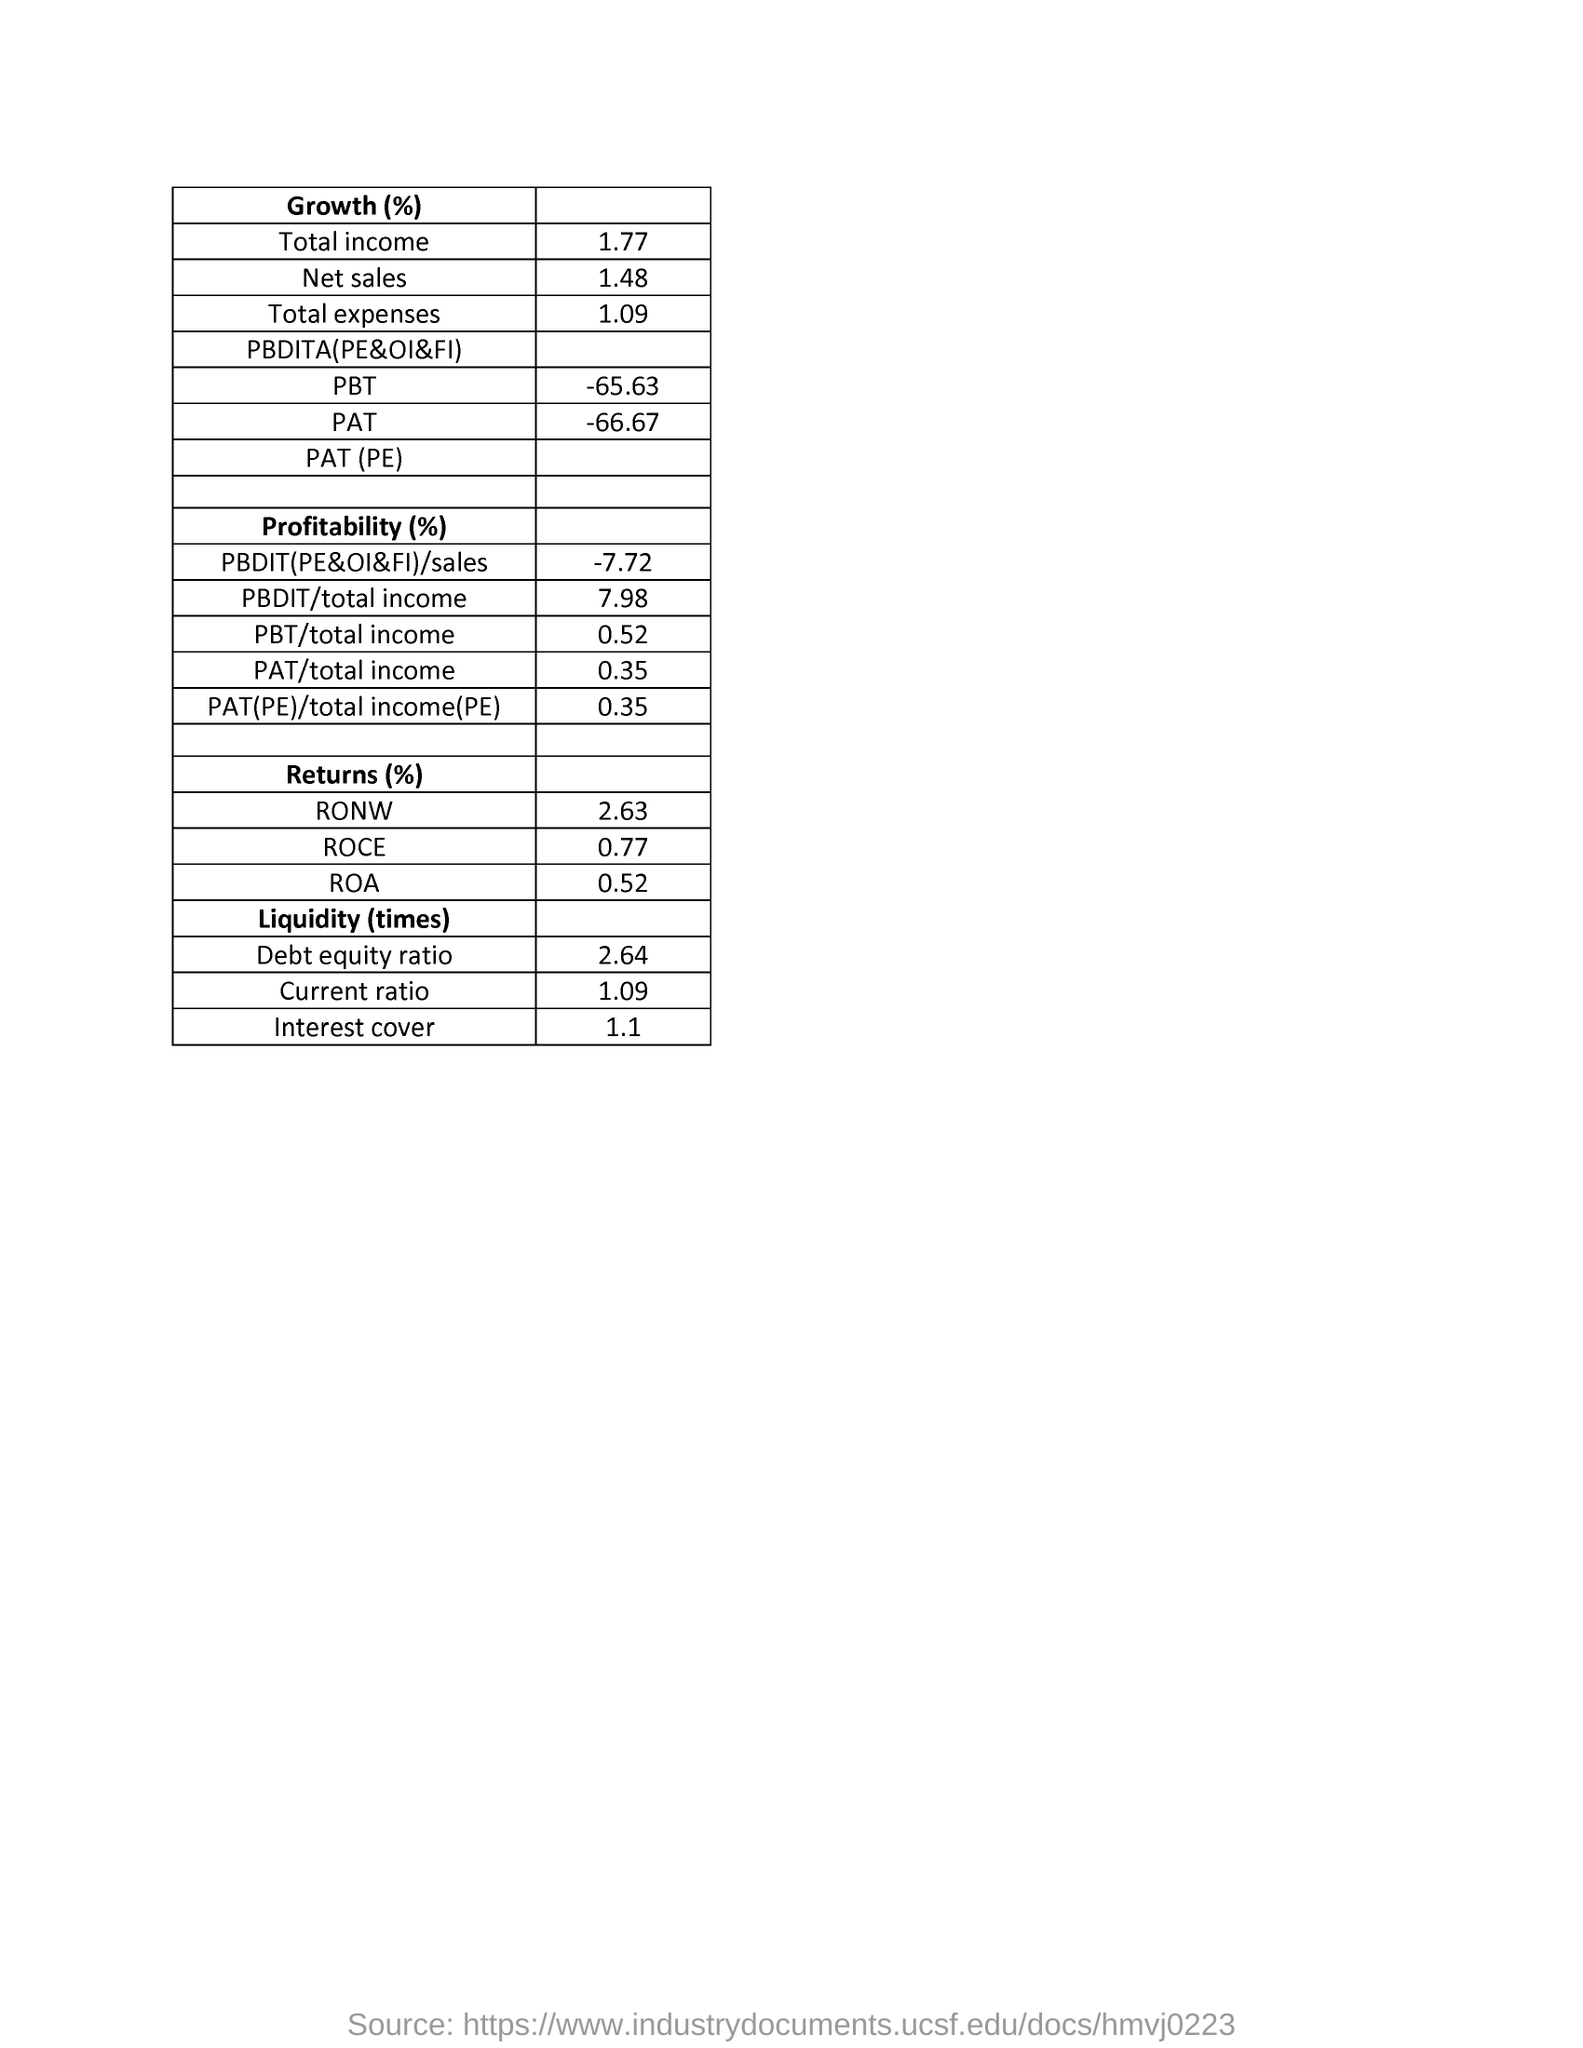Highlight a few significant elements in this photo. The value of ROCE in return is 0.77%. The total expenses in growth as a percentage was 1.09%. The Pat of Growth (%) is -66.67%. The total income growth percentage is 1.77. The PBT in growth was -65.63%. 